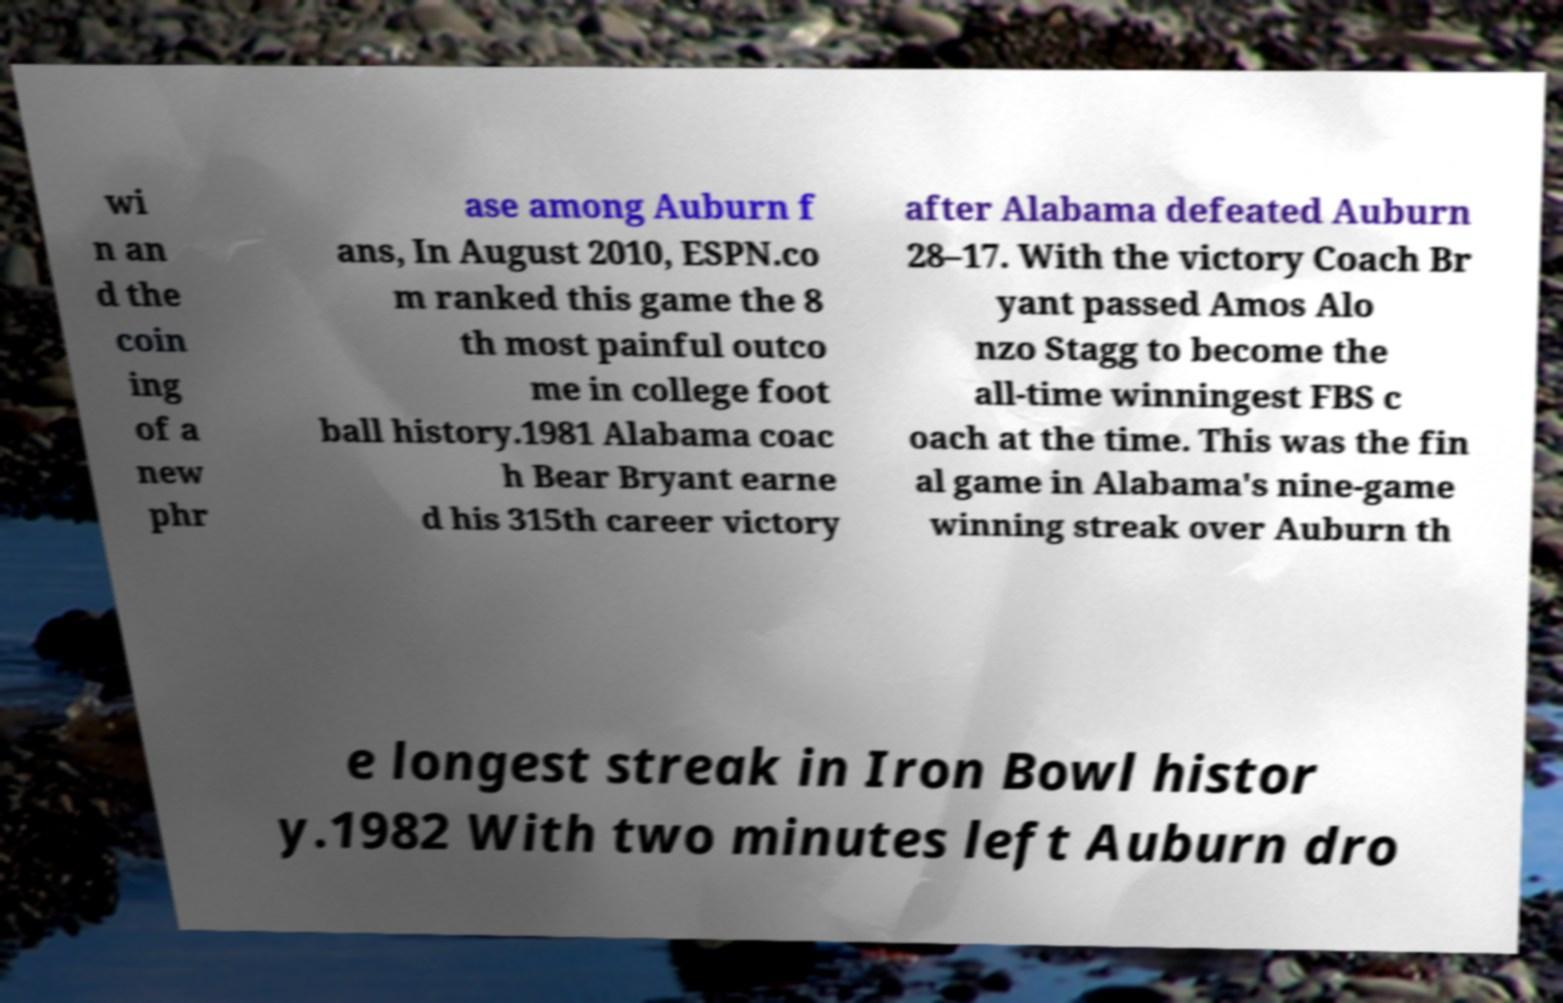Can you accurately transcribe the text from the provided image for me? wi n an d the coin ing of a new phr ase among Auburn f ans, In August 2010, ESPN.co m ranked this game the 8 th most painful outco me in college foot ball history.1981 Alabama coac h Bear Bryant earne d his 315th career victory after Alabama defeated Auburn 28–17. With the victory Coach Br yant passed Amos Alo nzo Stagg to become the all-time winningest FBS c oach at the time. This was the fin al game in Alabama's nine-game winning streak over Auburn th e longest streak in Iron Bowl histor y.1982 With two minutes left Auburn dro 